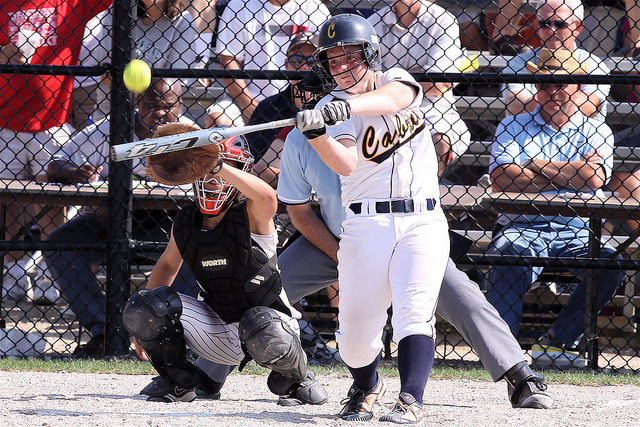Can you identify the uniforms of the teams? Yes. The batter is wearing a uniform that has 'Cavs' written on it, indicating she is from the Cavaliers team. The catcher is dressed in a darker uniform, though the specific team name is not visible, and the umpire is wearing neutral attire, typical of game officials. 